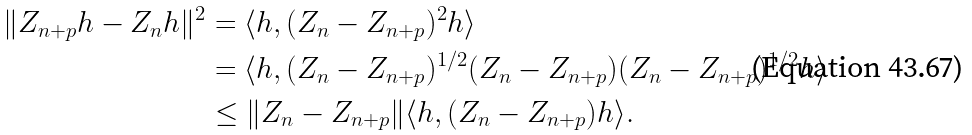<formula> <loc_0><loc_0><loc_500><loc_500>\| Z _ { n + p } h - Z _ { n } h \| ^ { 2 } & = \langle h , ( Z _ { n } - Z _ { n + p } ) ^ { 2 } h \rangle \\ & = \langle h , ( Z _ { n } - Z _ { n + p } ) ^ { 1 / 2 } ( Z _ { n } - Z _ { n + p } ) ( Z _ { n } - Z _ { n + p } ) ^ { 1 / 2 } h \rangle \\ & \leq \| Z _ { n } - Z _ { n + p } \| \langle h , ( Z _ { n } - Z _ { n + p } ) h \rangle .</formula> 